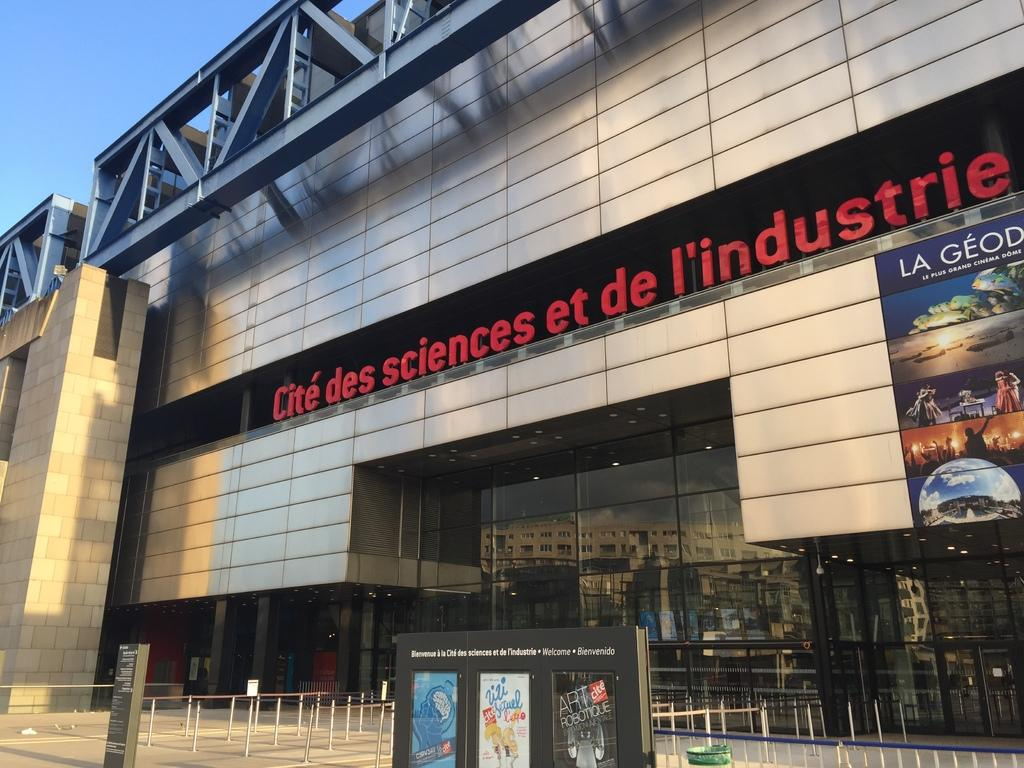<image>
Offer a succinct explanation of the picture presented. Large store with the words "Cite des sciences et de l'industrie" on top. 